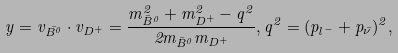<formula> <loc_0><loc_0><loc_500><loc_500>\ y = v _ { \bar { B ^ { 0 } } } \cdot v _ { D ^ { + } } = \frac { m _ { \bar { B } ^ { 0 } } ^ { 2 } + m _ { D ^ { + } } ^ { 2 } - q ^ { 2 } } { 2 m _ { \bar { B } ^ { 0 } } m _ { D ^ { + } } } , q ^ { 2 } = ( p _ { l ^ { - } } + p _ { \bar { \nu } } ) ^ { 2 } ,</formula> 